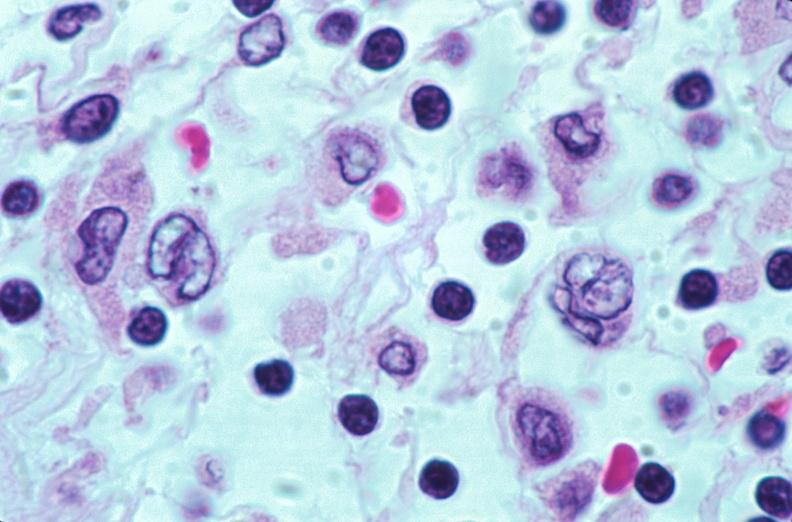does this image show lymph nodes, nodular sclerosing hodgkins disease?
Answer the question using a single word or phrase. Yes 